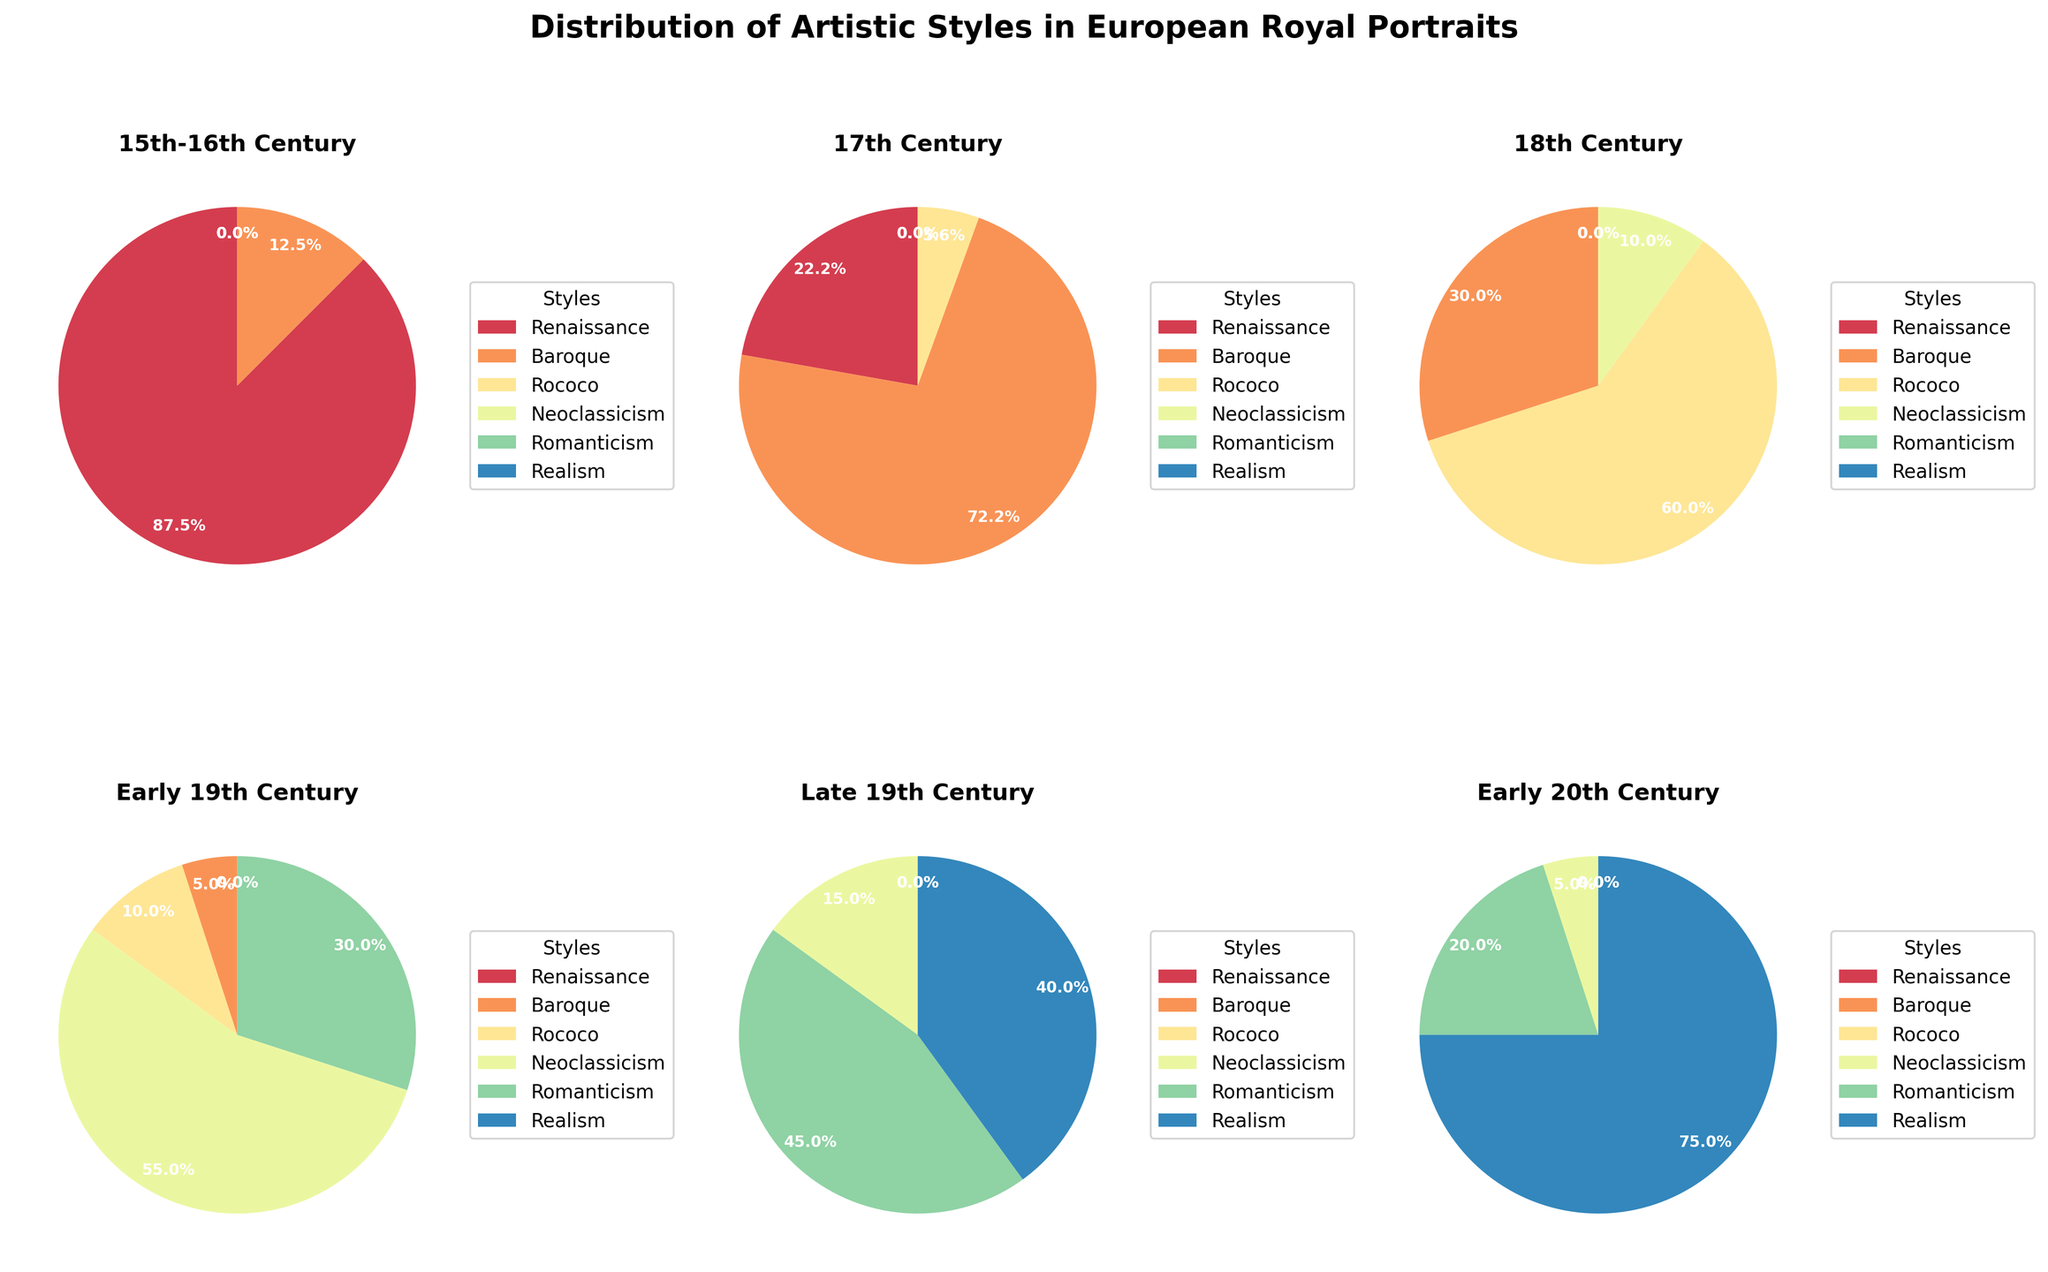What is the most common artistic style in the 15th-16th Century? The pie chart for the 15th-16th Century shows the distribution of artistic styles. The largest segment is Renaissance, indicating it is the most common.
Answer: Renaissance How does the proportion of Baroque style in the 17th Century compare to the Late 19th Century? The pie charts show that Baroque constitutes 65% in the 17th Century and 0% in the Late 19th Century. Thus, Baroque was significantly more prevalent in the 17th Century.
Answer: Greater What percentage of Rococo portraits are there in the 18th Century? The pie chart for the 18th Century shows that the Rococo style occupies 60% of the total proportion.
Answer: 60% Which era has the highest percentage of Neoclassicism style? By comparing the segments labeled 'Neoclassicism' across all pie charts, the Early 19th Century chart shows the largest Neoclassicism segment at 55%.
Answer: Early 19th Century Has the representation of Romanticism increased or decreased from Early to Late 19th Century? The pie charts show Romanticism at 30% in the Early 19th Century and 45% in the Late 19th Century, indicating an increase.
Answer: Increased Is there a century when Realism first appears and how dominant is it in that era? Realism first appears in the Late 19th Century pie chart, occupying 40% of the distribution.
Answer: Late 19th Century, 40% What era saw the disappearance of Renaissance portraits? The pie charts show that Renaissance is present in the 15th-16th and 17th Century but disappears by the 18th Century.
Answer: 18th Century Calculate the combined percentage of Neoclassicism and Romanticism in the Early 19th Century. The pie chart for the Early 19th Century shows Neoclassicism at 55% and Romanticism at 30%. Adding these gives 55% + 30% = 85%.
Answer: 85% Which era has the smallest proportion of Baroque style? Analyzing all pie charts, the eras other than the 17th and 18th Centuries have 0% Baroque, which is the smallest proportion.
Answer: 15th-16th Century, Early 19th Century, Late 19th Century, Early 20th Century What is the trend in the percentage of Realism from the Late 19th Century to the Early 20th Century? The pie charts show Realism percentages as 40% in the Late 19th Century and increasing to 75% in the Early 20th Century, indicating an upward trend.
Answer: Increasing 